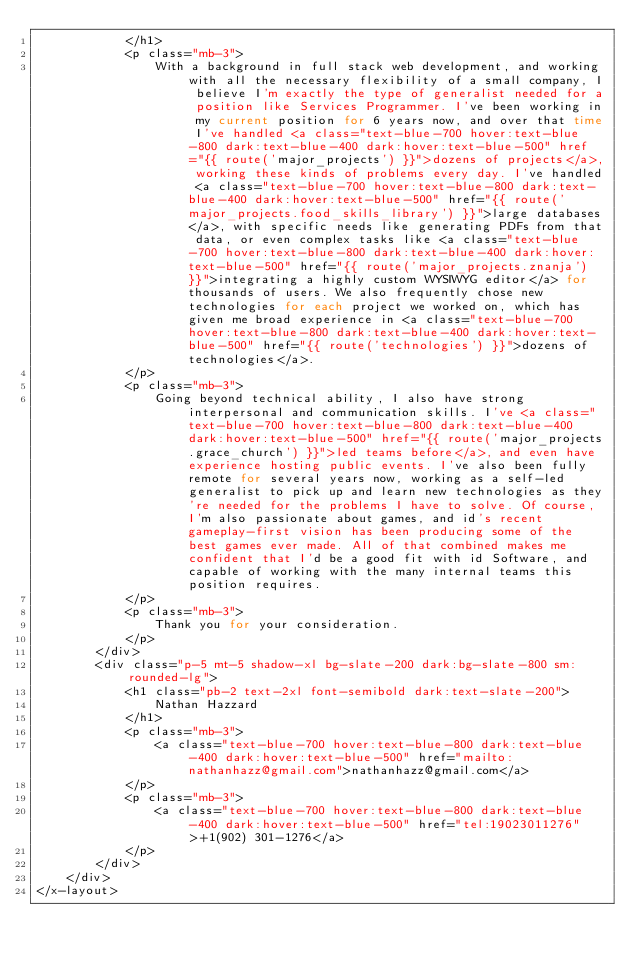<code> <loc_0><loc_0><loc_500><loc_500><_PHP_>            </h1>
            <p class="mb-3">
                With a background in full stack web development, and working with all the necessary flexibility of a small company, I believe I'm exactly the type of generalist needed for a position like Services Programmer. I've been working in my current position for 6 years now, and over that time I've handled <a class="text-blue-700 hover:text-blue-800 dark:text-blue-400 dark:hover:text-blue-500" href="{{ route('major_projects') }}">dozens of projects</a>, working these kinds of problems every day. I've handled <a class="text-blue-700 hover:text-blue-800 dark:text-blue-400 dark:hover:text-blue-500" href="{{ route('major_projects.food_skills_library') }}">large databases</a>, with specific needs like generating PDFs from that data, or even complex tasks like <a class="text-blue-700 hover:text-blue-800 dark:text-blue-400 dark:hover:text-blue-500" href="{{ route('major_projects.znanja') }}">integrating a highly custom WYSIWYG editor</a> for thousands of users. We also frequently chose new technologies for each project we worked on, which has given me broad experience in <a class="text-blue-700 hover:text-blue-800 dark:text-blue-400 dark:hover:text-blue-500" href="{{ route('technologies') }}">dozens of technologies</a>.
            </p>
            <p class="mb-3">
                Going beyond technical ability, I also have strong interpersonal and communication skills. I've <a class="text-blue-700 hover:text-blue-800 dark:text-blue-400 dark:hover:text-blue-500" href="{{ route('major_projects.grace_church') }}">led teams before</a>, and even have experience hosting public events. I've also been fully remote for several years now, working as a self-led generalist to pick up and learn new technologies as they're needed for the problems I have to solve. Of course, I'm also passionate about games, and id's recent gameplay-first vision has been producing some of the best games ever made. All of that combined makes me confident that I'd be a good fit with id Software, and capable of working with the many internal teams this position requires.
            </p>
            <p class="mb-3">
                Thank you for your consideration.
            </p>
        </div>
        <div class="p-5 mt-5 shadow-xl bg-slate-200 dark:bg-slate-800 sm:rounded-lg">
            <h1 class="pb-2 text-2xl font-semibold dark:text-slate-200">
                Nathan Hazzard
            </h1>
            <p class="mb-3">
                <a class="text-blue-700 hover:text-blue-800 dark:text-blue-400 dark:hover:text-blue-500" href="mailto:nathanhazz@gmail.com">nathanhazz@gmail.com</a>
            </p>
            <p class="mb-3">
                <a class="text-blue-700 hover:text-blue-800 dark:text-blue-400 dark:hover:text-blue-500" href="tel:19023011276">+1(902) 301-1276</a>
            </p>
        </div>
    </div>
</x-layout></code> 